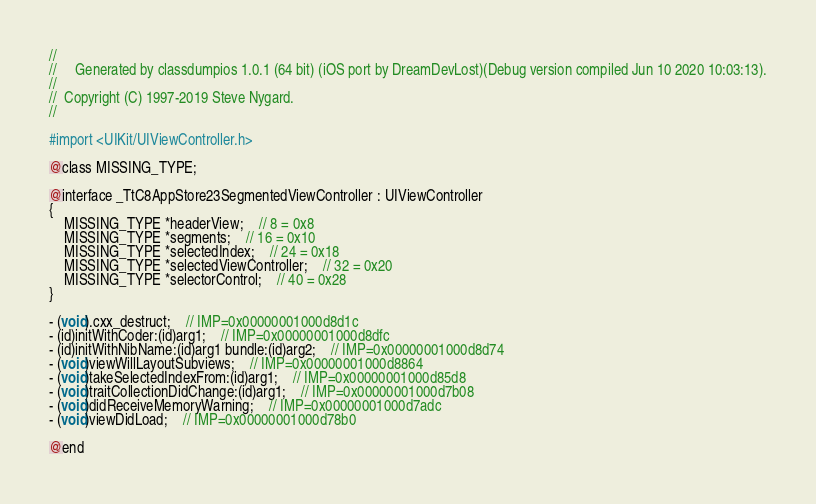<code> <loc_0><loc_0><loc_500><loc_500><_C_>//
//     Generated by classdumpios 1.0.1 (64 bit) (iOS port by DreamDevLost)(Debug version compiled Jun 10 2020 10:03:13).
//
//  Copyright (C) 1997-2019 Steve Nygard.
//

#import <UIKit/UIViewController.h>

@class MISSING_TYPE;

@interface _TtC8AppStore23SegmentedViewController : UIViewController
{
    MISSING_TYPE *headerView;	// 8 = 0x8
    MISSING_TYPE *segments;	// 16 = 0x10
    MISSING_TYPE *selectedIndex;	// 24 = 0x18
    MISSING_TYPE *selectedViewController;	// 32 = 0x20
    MISSING_TYPE *selectorControl;	// 40 = 0x28
}

- (void).cxx_destruct;	// IMP=0x00000001000d8d1c
- (id)initWithCoder:(id)arg1;	// IMP=0x00000001000d8dfc
- (id)initWithNibName:(id)arg1 bundle:(id)arg2;	// IMP=0x00000001000d8d74
- (void)viewWillLayoutSubviews;	// IMP=0x00000001000d8864
- (void)takeSelectedIndexFrom:(id)arg1;	// IMP=0x00000001000d85d8
- (void)traitCollectionDidChange:(id)arg1;	// IMP=0x00000001000d7b08
- (void)didReceiveMemoryWarning;	// IMP=0x00000001000d7adc
- (void)viewDidLoad;	// IMP=0x00000001000d78b0

@end

</code> 